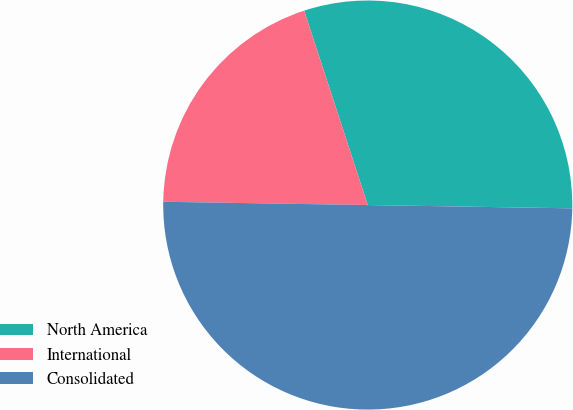Convert chart. <chart><loc_0><loc_0><loc_500><loc_500><pie_chart><fcel>North America<fcel>International<fcel>Consolidated<nl><fcel>30.29%<fcel>19.71%<fcel>50.0%<nl></chart> 